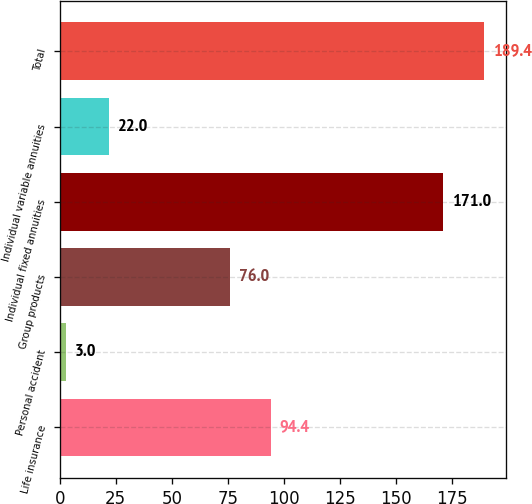<chart> <loc_0><loc_0><loc_500><loc_500><bar_chart><fcel>Life insurance<fcel>Personal accident<fcel>Group products<fcel>Individual fixed annuities<fcel>Individual variable annuities<fcel>Total<nl><fcel>94.4<fcel>3<fcel>76<fcel>171<fcel>22<fcel>189.4<nl></chart> 